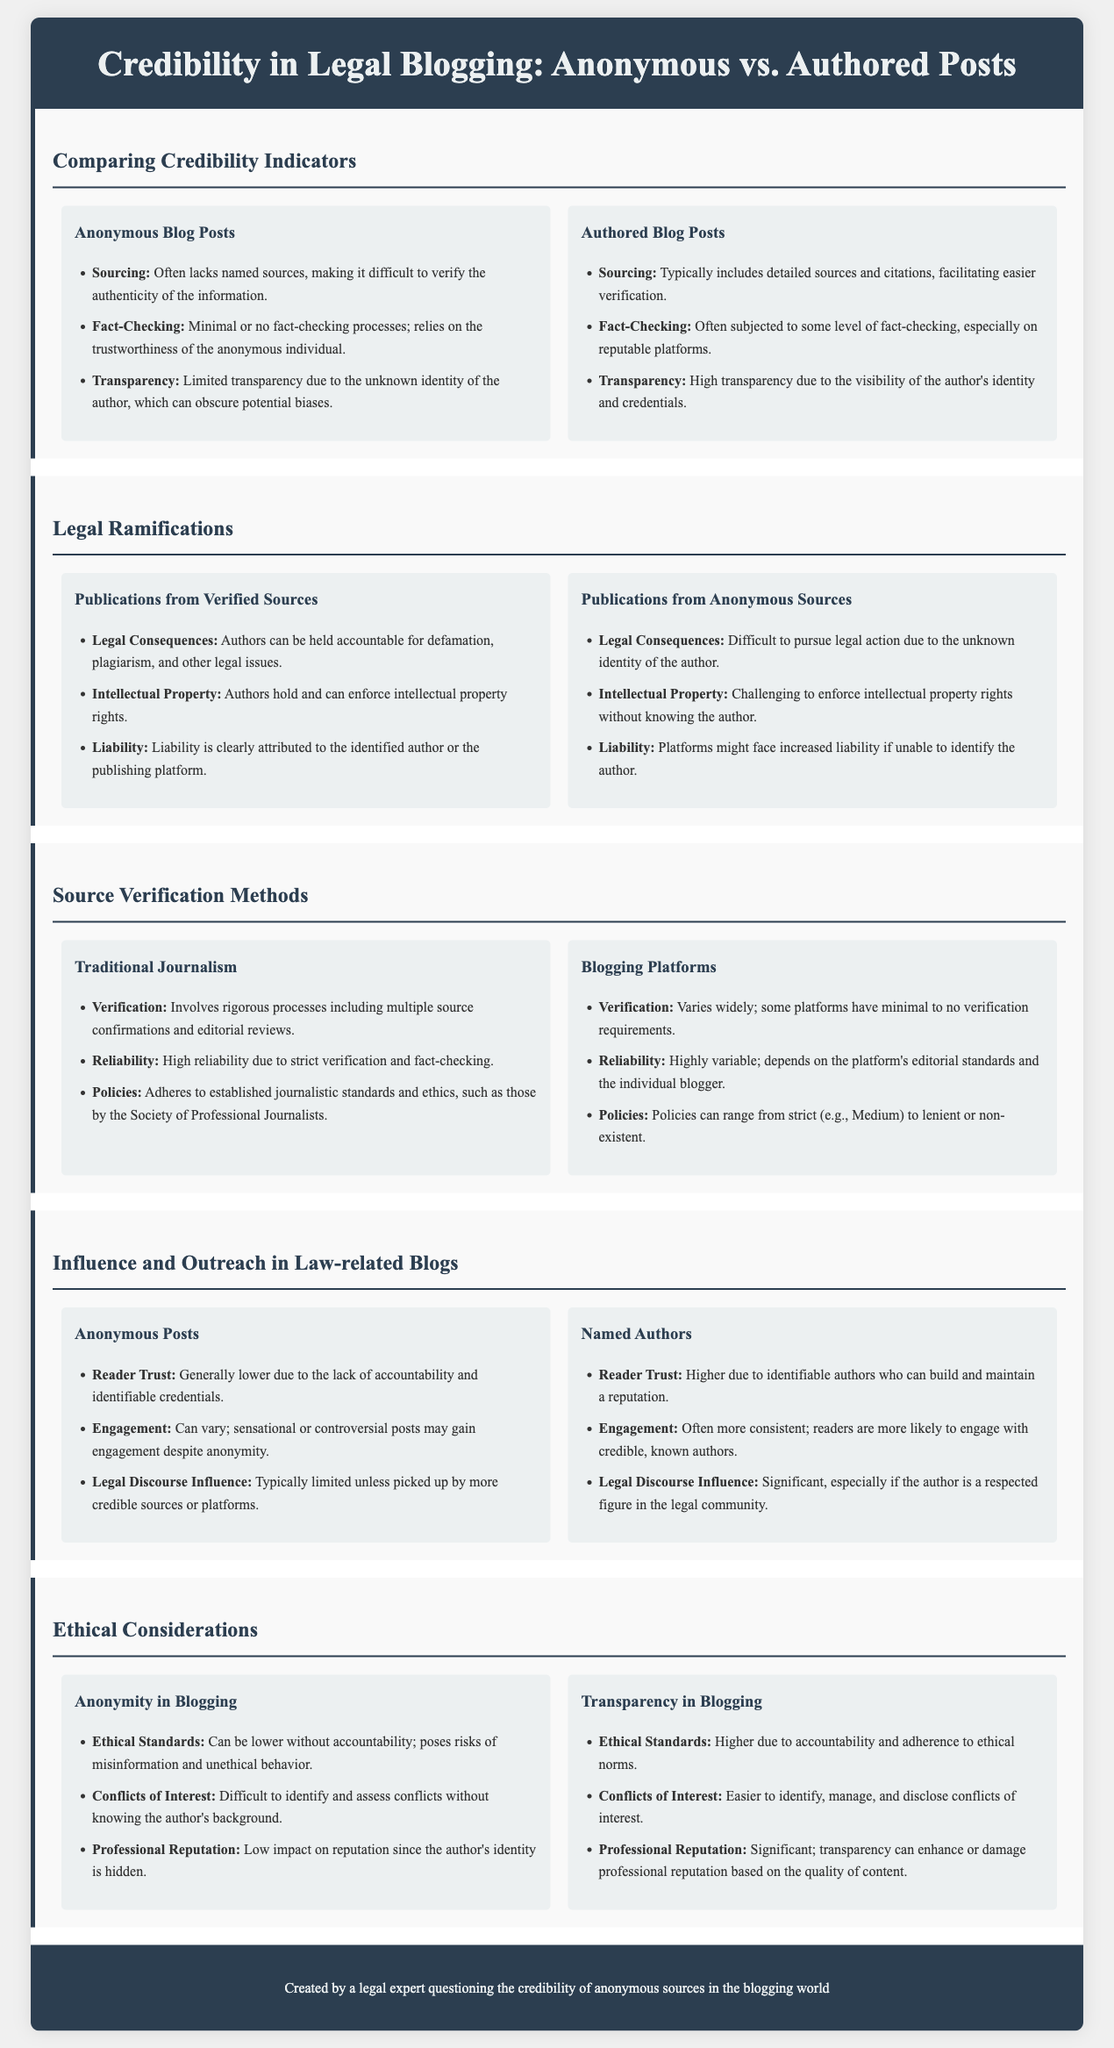What is the main theme of the infographic? The theme of the infographic revolves around comparing the credibility of anonymous versus authored blog posts specifically within the legal blogging domain.
Answer: Credibility in Legal Blogging How many sections are in the infographic? The infographic contains a total of five sections addressing different aspects of anonymous and authored posts.
Answer: Five What is a key sourcing difference between anonymous and authored blog posts? Anonymous blog posts often lack named sources, while authored blog posts typically include detailed sources and citations.
Answer: Lack of named sources What are legal consequences for publications from verified sources? Authors can be held accountable for defamation, plagiarism, and other legal issues with verified sources.
Answer: Defamation In terms of reader trust, which type of posts generally fares better? Named authors generally enjoy higher reader trust compared to anonymous posts.
Answer: Named authors What is a potential risk of anonymity in blogging? Anonymity can lead to lower ethical standards and misinformation without accountability.
Answer: Misinformation Which blog type has more variable reliability? Blogging platforms have a highly variable reliability depending on the platform's editorial standards.
Answer: Blogging platforms What ethical concern is highlighted in the comparison of anonymity and transparency? Anonymity poses risks of misinformation, while transparency enhances ethical standards.
Answer: Misinformation What is the impact of transparency on professional reputation? Transparency can significantly enhance or damage an individual's professional reputation based on content quality.
Answer: Significant impact 